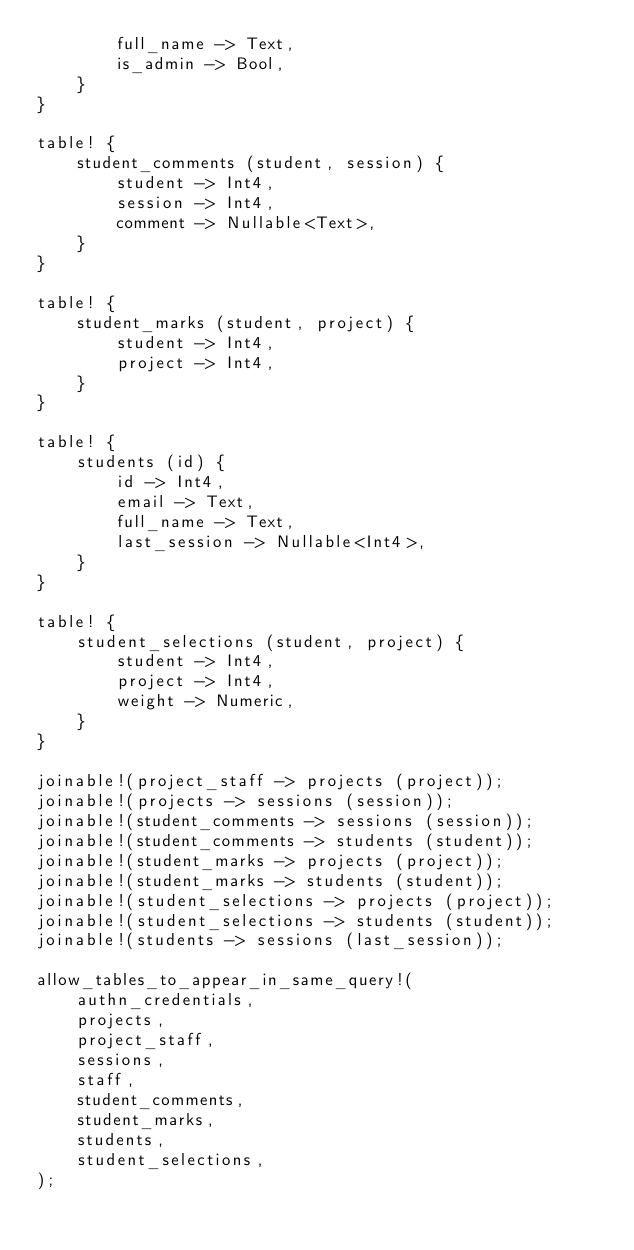Convert code to text. <code><loc_0><loc_0><loc_500><loc_500><_Rust_>        full_name -> Text,
        is_admin -> Bool,
    }
}

table! {
    student_comments (student, session) {
        student -> Int4,
        session -> Int4,
        comment -> Nullable<Text>,
    }
}

table! {
    student_marks (student, project) {
        student -> Int4,
        project -> Int4,
    }
}

table! {
    students (id) {
        id -> Int4,
        email -> Text,
        full_name -> Text,
        last_session -> Nullable<Int4>,
    }
}

table! {
    student_selections (student, project) {
        student -> Int4,
        project -> Int4,
        weight -> Numeric,
    }
}

joinable!(project_staff -> projects (project));
joinable!(projects -> sessions (session));
joinable!(student_comments -> sessions (session));
joinable!(student_comments -> students (student));
joinable!(student_marks -> projects (project));
joinable!(student_marks -> students (student));
joinable!(student_selections -> projects (project));
joinable!(student_selections -> students (student));
joinable!(students -> sessions (last_session));

allow_tables_to_appear_in_same_query!(
    authn_credentials,
    projects,
    project_staff,
    sessions,
    staff,
    student_comments,
    student_marks,
    students,
    student_selections,
);
</code> 